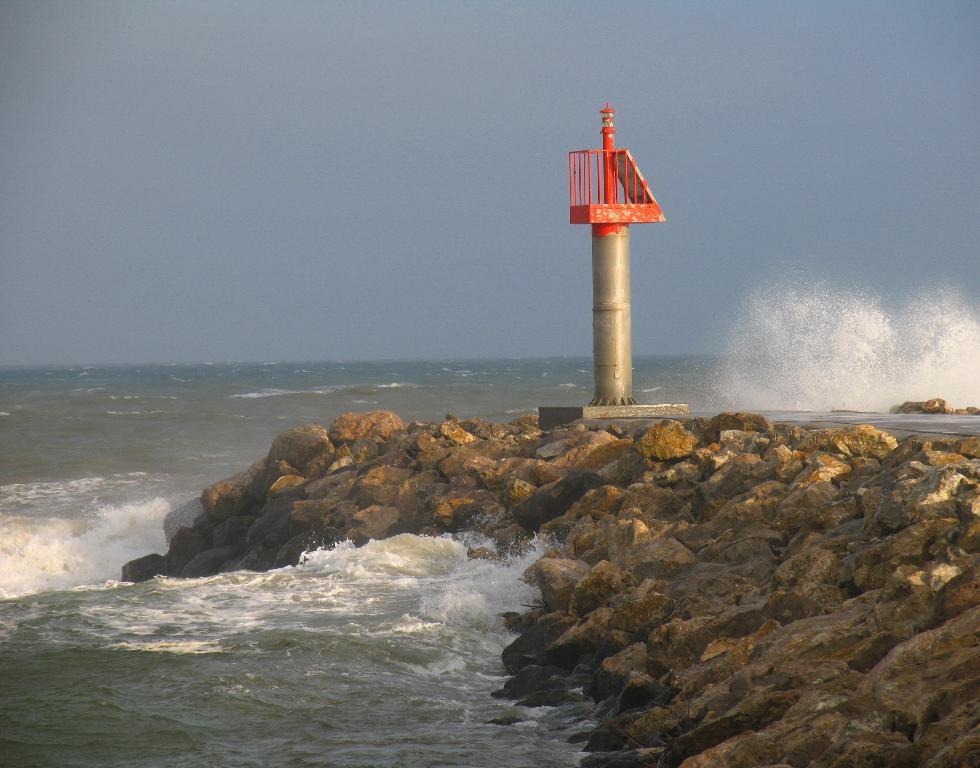In one or two sentences, can you explain what this image depicts? In this image in the center there is water and in the front there are stones and there is a pole which is silver and red in colour. 